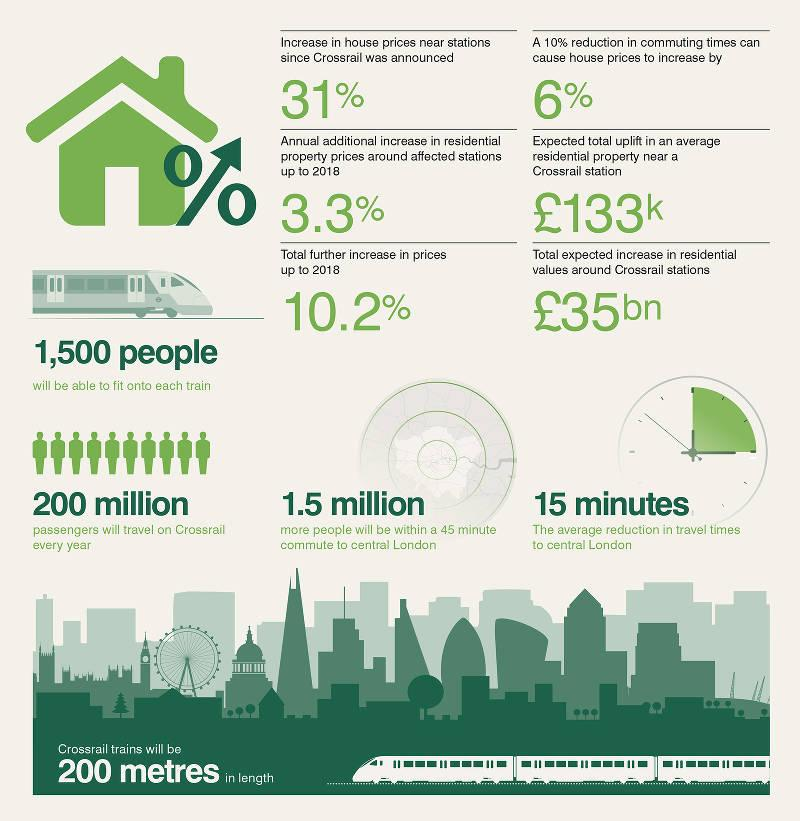List a handful of essential elements in this visual. The average reduction in travel times to central London is expected to be approximately 15 minutes. Crossrail has the capacity to transport up to 200 million passengers annually. The additional increase in property prices near train stations from 2000 to 2018 was 3.3%. The estimated number of people who will be within a 45-minute commute of central London when the Crossrail is functional is 1.5 million. The decrease in commuting times led to a 6% increase in house prices. 